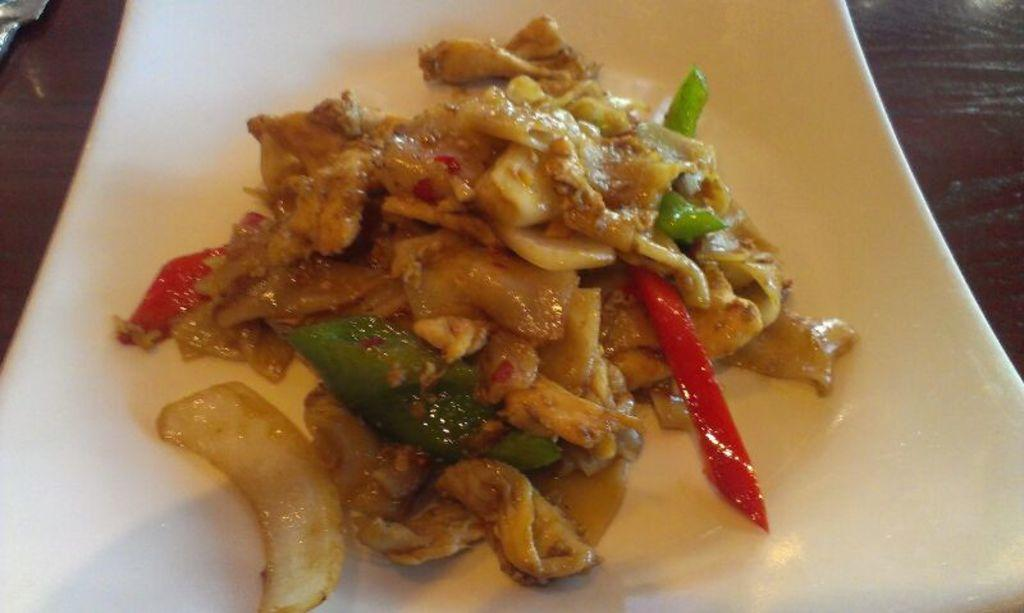What is on the plate that is visible in the image? There is food on the plate in the image. Where is the plate located in the image? The plate is on a table in the image. What can be seen in the left side top corner of the image? There is an object in the left side top corner of the image. Can you see your dad in the image? There is no reference to a dad or any person in the image, so it is not possible to determine if your dad is present. 